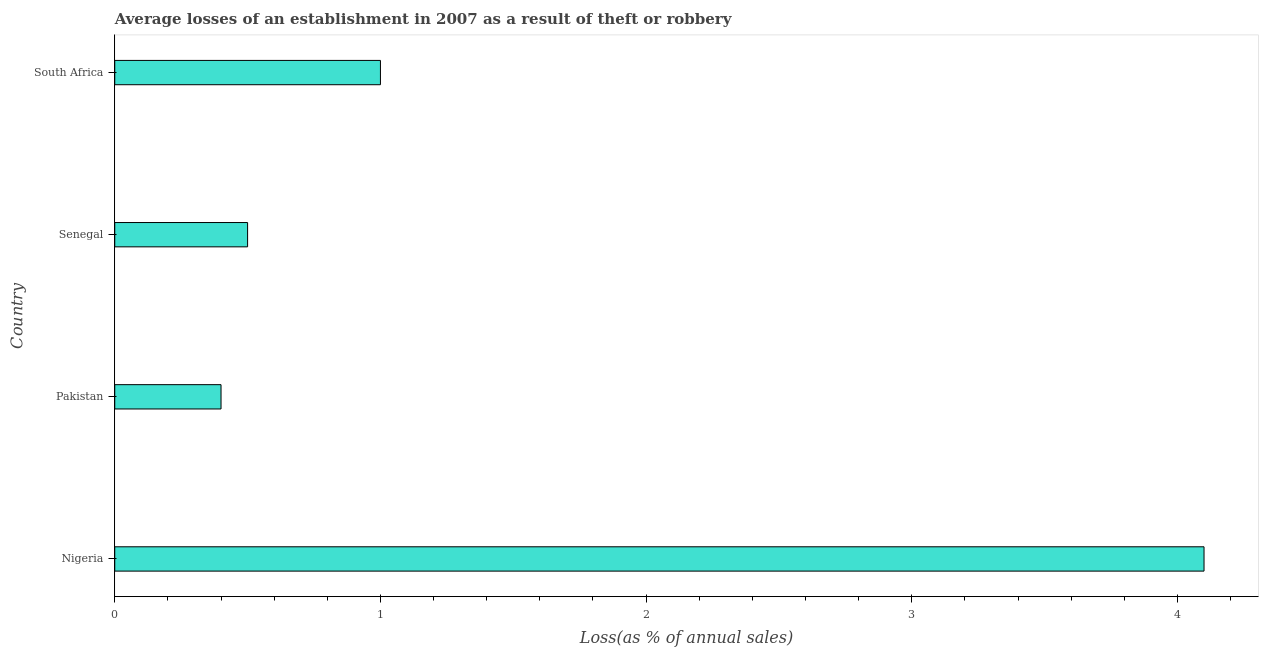Does the graph contain grids?
Ensure brevity in your answer.  No. What is the title of the graph?
Give a very brief answer. Average losses of an establishment in 2007 as a result of theft or robbery. What is the label or title of the X-axis?
Keep it short and to the point. Loss(as % of annual sales). What is the losses due to theft in Senegal?
Provide a succinct answer. 0.5. In which country was the losses due to theft maximum?
Your answer should be very brief. Nigeria. In which country was the losses due to theft minimum?
Make the answer very short. Pakistan. What is the difference between the losses due to theft in Pakistan and Senegal?
Your answer should be very brief. -0.1. In how many countries, is the losses due to theft greater than 3.4 %?
Your answer should be very brief. 1. What is the ratio of the losses due to theft in Pakistan to that in Senegal?
Provide a short and direct response. 0.8. Is the difference between the losses due to theft in Nigeria and Senegal greater than the difference between any two countries?
Offer a very short reply. No. Is the sum of the losses due to theft in Pakistan and South Africa greater than the maximum losses due to theft across all countries?
Make the answer very short. No. What is the difference between the highest and the lowest losses due to theft?
Ensure brevity in your answer.  3.7. How many bars are there?
Your answer should be very brief. 4. Are the values on the major ticks of X-axis written in scientific E-notation?
Give a very brief answer. No. What is the Loss(as % of annual sales) of Nigeria?
Provide a succinct answer. 4.1. What is the Loss(as % of annual sales) in Pakistan?
Provide a succinct answer. 0.4. What is the Loss(as % of annual sales) of South Africa?
Your response must be concise. 1. What is the difference between the Loss(as % of annual sales) in Nigeria and Pakistan?
Your answer should be compact. 3.7. What is the difference between the Loss(as % of annual sales) in Senegal and South Africa?
Give a very brief answer. -0.5. What is the ratio of the Loss(as % of annual sales) in Nigeria to that in Pakistan?
Your answer should be very brief. 10.25. What is the ratio of the Loss(as % of annual sales) in Nigeria to that in Senegal?
Give a very brief answer. 8.2. What is the ratio of the Loss(as % of annual sales) in Nigeria to that in South Africa?
Give a very brief answer. 4.1. What is the ratio of the Loss(as % of annual sales) in Pakistan to that in Senegal?
Provide a succinct answer. 0.8. What is the ratio of the Loss(as % of annual sales) in Pakistan to that in South Africa?
Keep it short and to the point. 0.4. What is the ratio of the Loss(as % of annual sales) in Senegal to that in South Africa?
Offer a terse response. 0.5. 